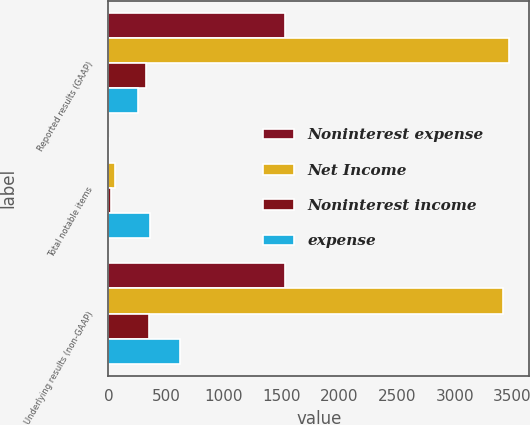<chart> <loc_0><loc_0><loc_500><loc_500><stacked_bar_chart><ecel><fcel>Reported results (GAAP)<fcel>Total notable items<fcel>Underlying results (non-GAAP)<nl><fcel>Noninterest expense<fcel>1534<fcel>6<fcel>1528<nl><fcel>Net Income<fcel>3474<fcel>55<fcel>3419<nl><fcel>Noninterest income<fcel>321<fcel>26<fcel>347<nl><fcel>expense<fcel>260<fcel>363<fcel>623<nl></chart> 